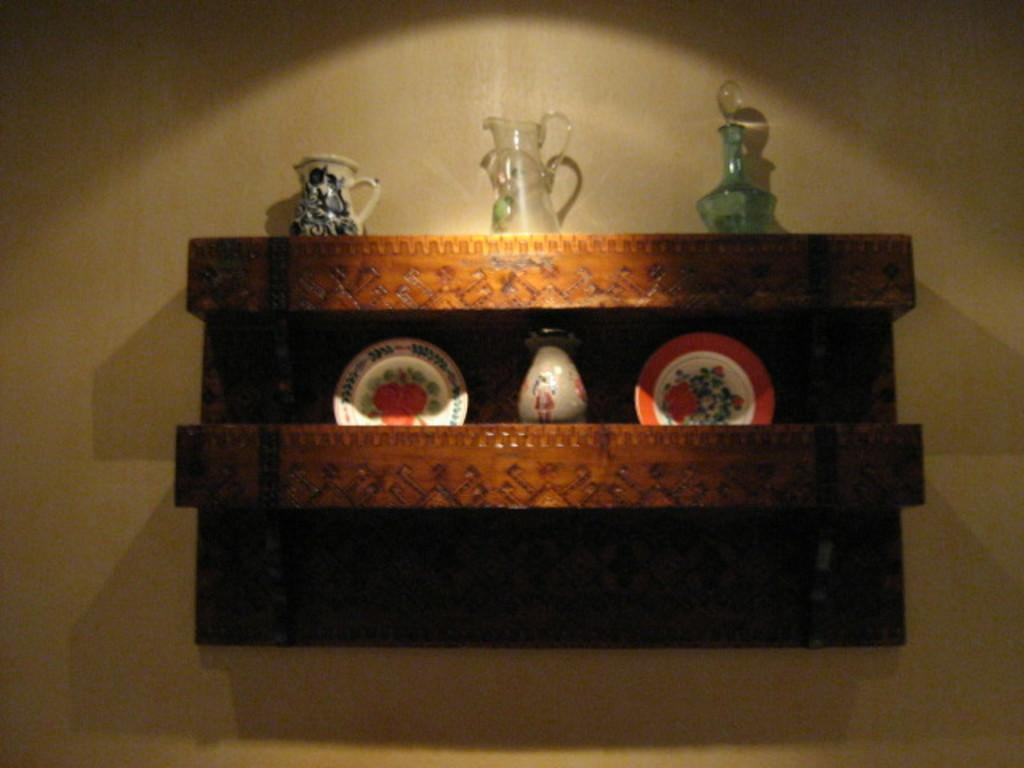What type of furniture is on the wall in the image? There is a wooden shelf on the wall in the image. What items are placed on the wooden shelf? There are plates and jugs on the shelf. What type of weightlifting system is visible on the wooden shelf in the image? There is no weightlifting system visible on the wooden shelf in the image. Who is the secretary responsible for organizing the items on the wooden shelf in the image? There is no secretary mentioned or visible in the image. 